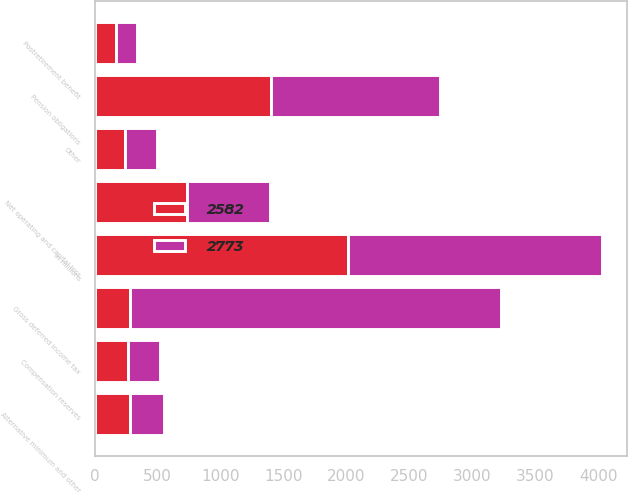<chart> <loc_0><loc_0><loc_500><loc_500><stacked_bar_chart><ecel><fcel>In millions<fcel>Postretirement benefit<fcel>Pension obligations<fcel>Alternative minimum and other<fcel>Net operating and capital loss<fcel>Compensation reserves<fcel>Other<fcel>Gross deferred income tax<nl><fcel>2773<fcel>2016<fcel>165<fcel>1344<fcel>270<fcel>662<fcel>257<fcel>251<fcel>2949<nl><fcel>2582<fcel>2015<fcel>172<fcel>1403<fcel>283<fcel>732<fcel>265<fcel>244<fcel>283<nl></chart> 